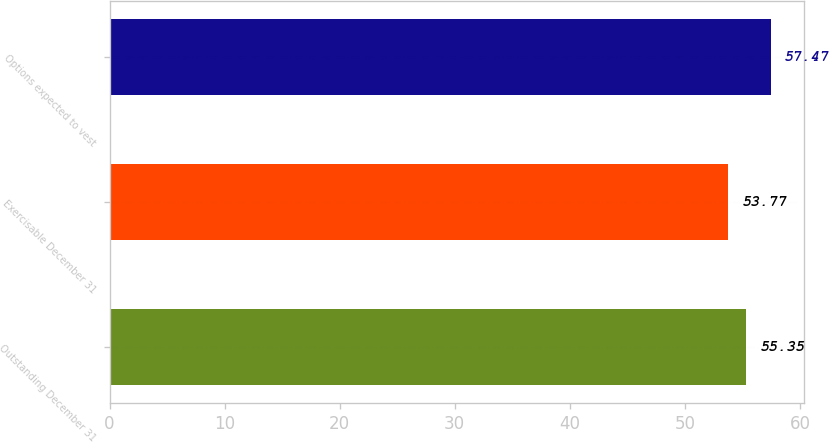<chart> <loc_0><loc_0><loc_500><loc_500><bar_chart><fcel>Outstanding December 31<fcel>Exercisable December 31<fcel>Options expected to vest<nl><fcel>55.35<fcel>53.77<fcel>57.47<nl></chart> 